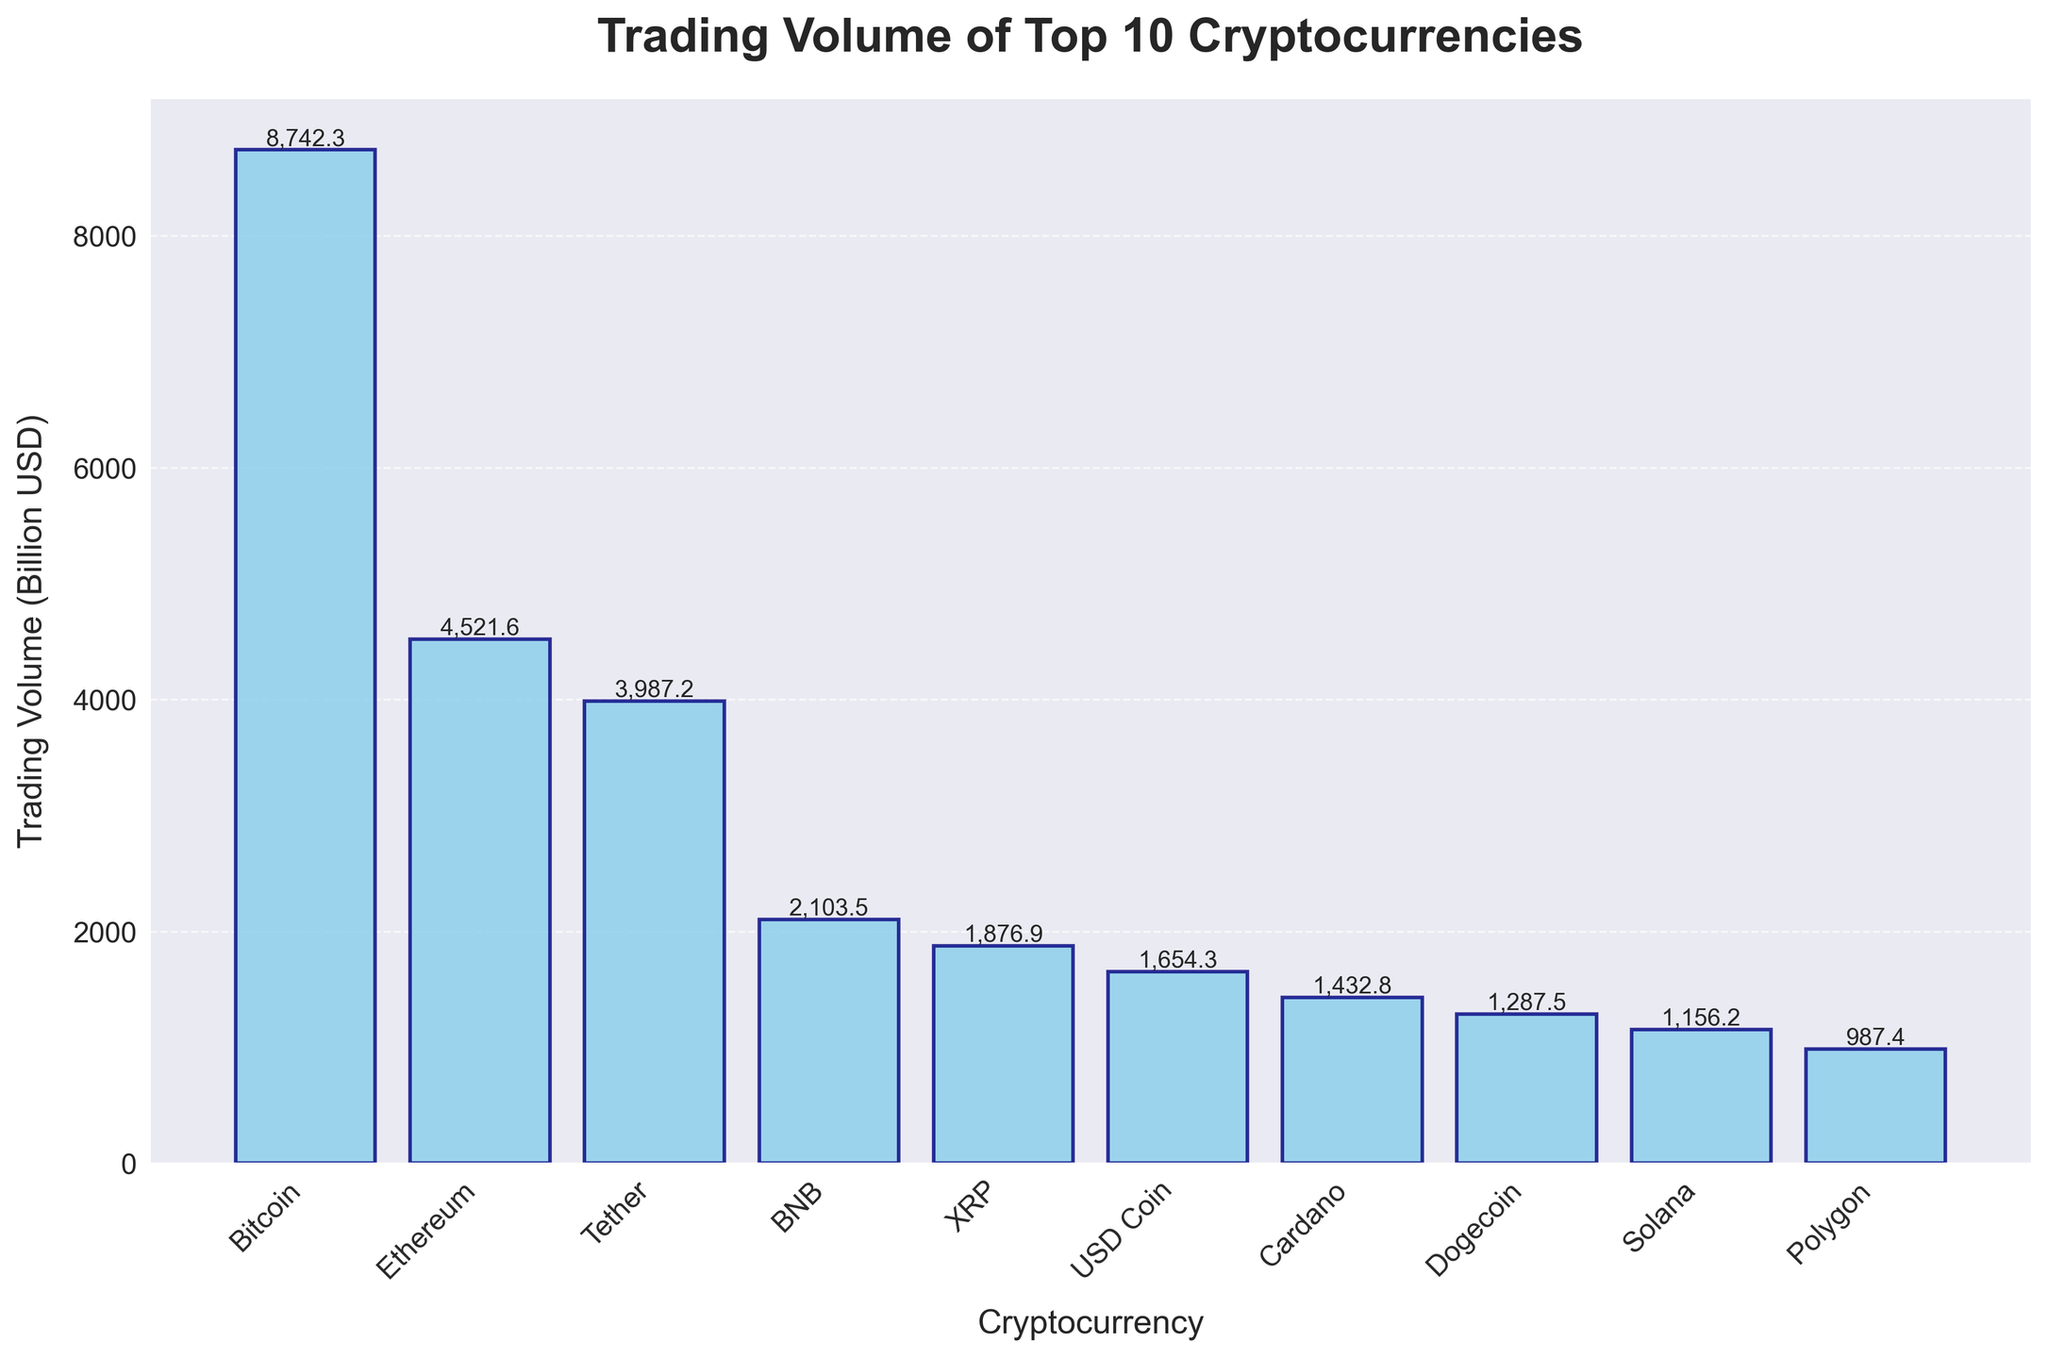what is the cryptocurrency with the highest trading volume over the past year? The bar corresponding to Bitcoin is the tallest, indicating it has the highest trading volume among the top 10 cryptocurrencies.
Answer: Bitcoin Which cryptocurrency has the lowest trading volume in the chart? The bar corresponding to Polygon is the shortest, indicating it has the lowest trading volume among the top 10 cryptocurrencies.
Answer: Polygon How much higher is Bitcoin's trading volume compared to Ethereum's? Bitcoin's trading volume is 8742.3 billion USD and Ethereum's volume is 4521.6 billion USD. The difference is 8742.3 - 4521.6 = 4220.7 billion USD.
Answer: 4220.7 billion USD What is the average trading volume of BNB, XRP, and USD Coin? BNB has 2103.5 billion USD, XRP has 1876.9 billion USD, and USD Coin has 1654.3 billion USD. Summing these gives 2103.5 + 1876.9 + 1654.3 = 5634.7 billion USD. Dividing by 3, the average is 5634.7 / 3 ≈ 1878.2 billion USD.
Answer: 1878.2 billion USD Which cryptocurrencies have higher trading volumes than Tether? Bitcoin and Ethereum have taller bars compared to Tether, indicating higher trading volumes.
Answer: Bitcoin, Ethereum What is the total trading volume of the top 5 cryptocurrencies in the chart? The trading volumes are Bitcoin: 8742.3, Ethereum: 4521.6, Tether: 3987.2, BNB: 2103.5, and XRP: 1876.9. Summing these gives 8742.3 + 4521.6 + 3987.2 + 2103.5 + 1876.9 = 21231.5 billion USD.
Answer: 21231.5 billion USD Between Dogecoin and Solana, which has a higher trading volume and by how much? Dogecoin has a trading volume of 1287.5 billion USD, and Solana has 1156.2 billion USD. The difference is 1287.5 - 1156.2 = 131.3 billion USD.
Answer: Dogecoin by 131.3 billion USD Which cryptocurrencies have trading volumes between 1000 billion USD and 2000 billion USD? The bars corresponding to BNB, XRP, USD Coin, Cardano, Dogecoin, and Solana fall within the range of 1000 billion USD to 2000 billion USD.
Answer: BNB, XRP, USD Coin, Cardano, Dogecoin, Solana What is the percentage of Bitcoin's trading volume relative to the total trading volume of all the top 10 cryptocurrencies? The total trading volume is the sum of all volumes: 8742.3 + 4521.6 + 3987.2 + 2103.5 + 1876.9 + 1654.3 + 1432.8 + 1287.5 + 1156.2 + 987.4 = 27649.7 billion USD. The percentage is (8742.3 / 27649.7) * 100 ≈ 31.6%.
Answer: 31.6% 